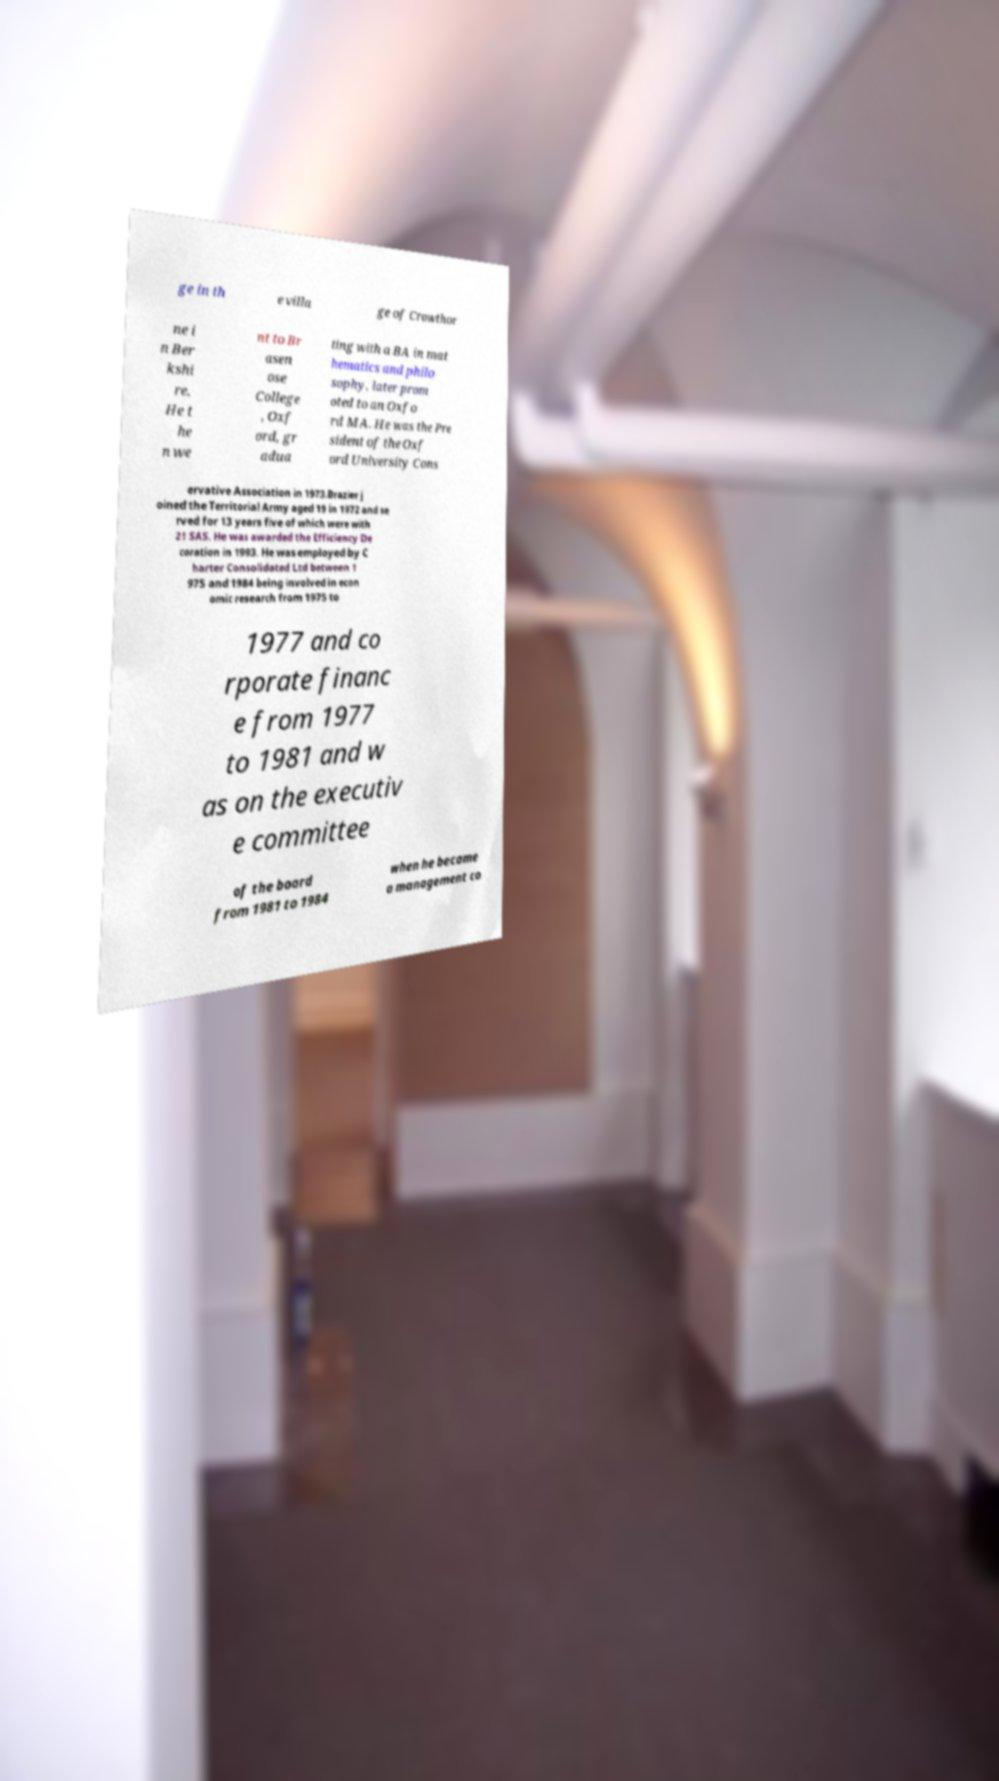Please identify and transcribe the text found in this image. ge in th e villa ge of Crowthor ne i n Ber kshi re. He t he n we nt to Br asen ose College , Oxf ord, gr adua ting with a BA in mat hematics and philo sophy, later prom oted to an Oxfo rd MA. He was the Pre sident of the Oxf ord University Cons ervative Association in 1973.Brazier j oined the Territorial Army aged 19 in 1972 and se rved for 13 years five of which were with 21 SAS. He was awarded the Efficiency De coration in 1993. He was employed by C harter Consolidated Ltd between 1 975 and 1984 being involved in econ omic research from 1975 to 1977 and co rporate financ e from 1977 to 1981 and w as on the executiv e committee of the board from 1981 to 1984 when he became a management co 